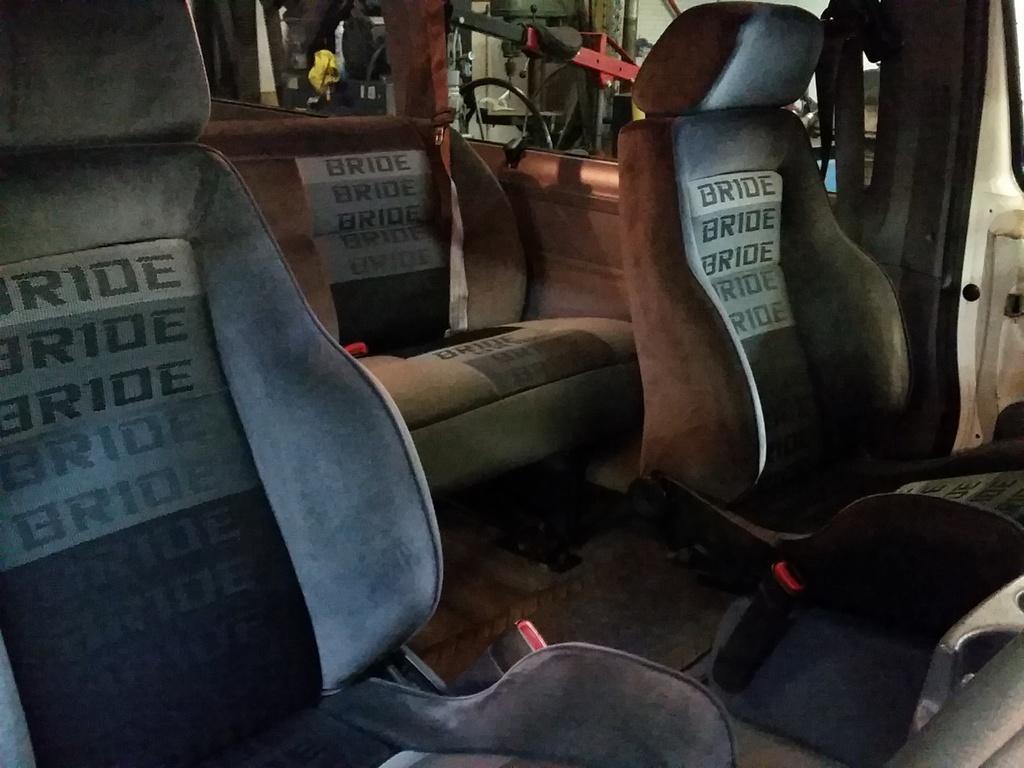In one or two sentences, can you explain what this image depicts? This image is taken inside the vehicle. In this image we can see the seats. We can also see some objects in the background. We can see the text on the seats. 